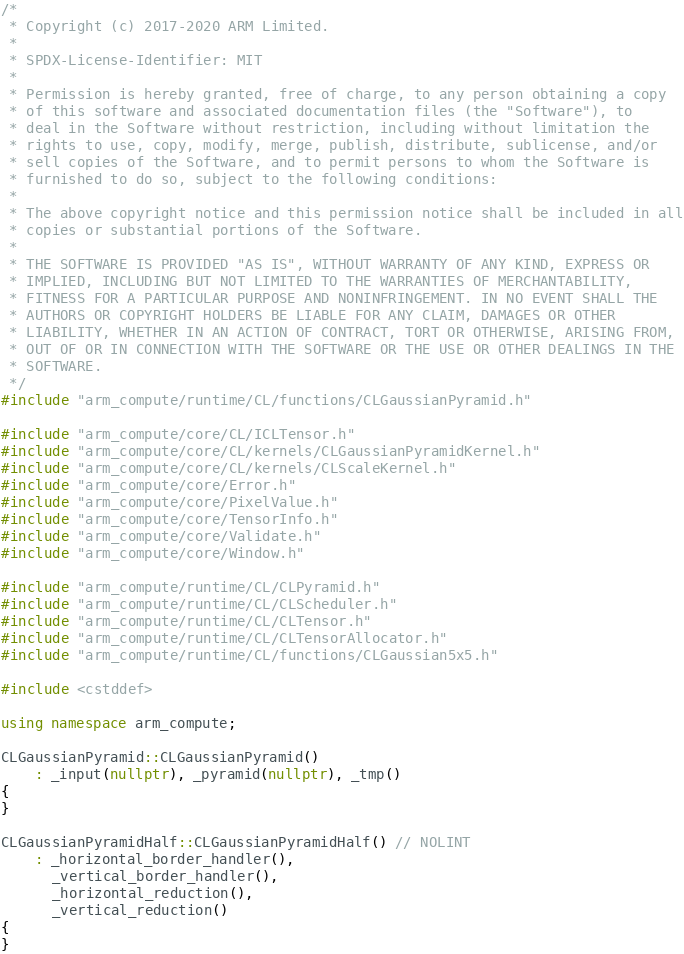<code> <loc_0><loc_0><loc_500><loc_500><_C++_>/*
 * Copyright (c) 2017-2020 ARM Limited.
 *
 * SPDX-License-Identifier: MIT
 *
 * Permission is hereby granted, free of charge, to any person obtaining a copy
 * of this software and associated documentation files (the "Software"), to
 * deal in the Software without restriction, including without limitation the
 * rights to use, copy, modify, merge, publish, distribute, sublicense, and/or
 * sell copies of the Software, and to permit persons to whom the Software is
 * furnished to do so, subject to the following conditions:
 *
 * The above copyright notice and this permission notice shall be included in all
 * copies or substantial portions of the Software.
 *
 * THE SOFTWARE IS PROVIDED "AS IS", WITHOUT WARRANTY OF ANY KIND, EXPRESS OR
 * IMPLIED, INCLUDING BUT NOT LIMITED TO THE WARRANTIES OF MERCHANTABILITY,
 * FITNESS FOR A PARTICULAR PURPOSE AND NONINFRINGEMENT. IN NO EVENT SHALL THE
 * AUTHORS OR COPYRIGHT HOLDERS BE LIABLE FOR ANY CLAIM, DAMAGES OR OTHER
 * LIABILITY, WHETHER IN AN ACTION OF CONTRACT, TORT OR OTHERWISE, ARISING FROM,
 * OUT OF OR IN CONNECTION WITH THE SOFTWARE OR THE USE OR OTHER DEALINGS IN THE
 * SOFTWARE.
 */
#include "arm_compute/runtime/CL/functions/CLGaussianPyramid.h"

#include "arm_compute/core/CL/ICLTensor.h"
#include "arm_compute/core/CL/kernels/CLGaussianPyramidKernel.h"
#include "arm_compute/core/CL/kernels/CLScaleKernel.h"
#include "arm_compute/core/Error.h"
#include "arm_compute/core/PixelValue.h"
#include "arm_compute/core/TensorInfo.h"
#include "arm_compute/core/Validate.h"
#include "arm_compute/core/Window.h"

#include "arm_compute/runtime/CL/CLPyramid.h"
#include "arm_compute/runtime/CL/CLScheduler.h"
#include "arm_compute/runtime/CL/CLTensor.h"
#include "arm_compute/runtime/CL/CLTensorAllocator.h"
#include "arm_compute/runtime/CL/functions/CLGaussian5x5.h"

#include <cstddef>

using namespace arm_compute;

CLGaussianPyramid::CLGaussianPyramid()
    : _input(nullptr), _pyramid(nullptr), _tmp()
{
}

CLGaussianPyramidHalf::CLGaussianPyramidHalf() // NOLINT
    : _horizontal_border_handler(),
      _vertical_border_handler(),
      _horizontal_reduction(),
      _vertical_reduction()
{
}
</code> 